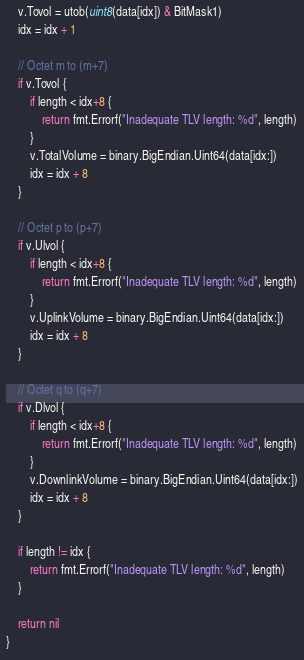Convert code to text. <code><loc_0><loc_0><loc_500><loc_500><_Go_>	v.Tovol = utob(uint8(data[idx]) & BitMask1)
	idx = idx + 1

	// Octet m to (m+7)
	if v.Tovol {
		if length < idx+8 {
			return fmt.Errorf("Inadequate TLV length: %d", length)
		}
		v.TotalVolume = binary.BigEndian.Uint64(data[idx:])
		idx = idx + 8
	}

	// Octet p to (p+7)
	if v.Ulvol {
		if length < idx+8 {
			return fmt.Errorf("Inadequate TLV length: %d", length)
		}
		v.UplinkVolume = binary.BigEndian.Uint64(data[idx:])
		idx = idx + 8
	}

	// Octet q to (q+7)
	if v.Dlvol {
		if length < idx+8 {
			return fmt.Errorf("Inadequate TLV length: %d", length)
		}
		v.DownlinkVolume = binary.BigEndian.Uint64(data[idx:])
		idx = idx + 8
	}

	if length != idx {
		return fmt.Errorf("Inadequate TLV length: %d", length)
	}

	return nil
}
</code> 